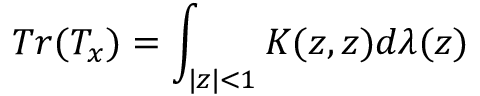Convert formula to latex. <formula><loc_0><loc_0><loc_500><loc_500>T r ( T _ { x } ) = \int _ { | z | < 1 } K ( z , z ) d \lambda ( z )</formula> 